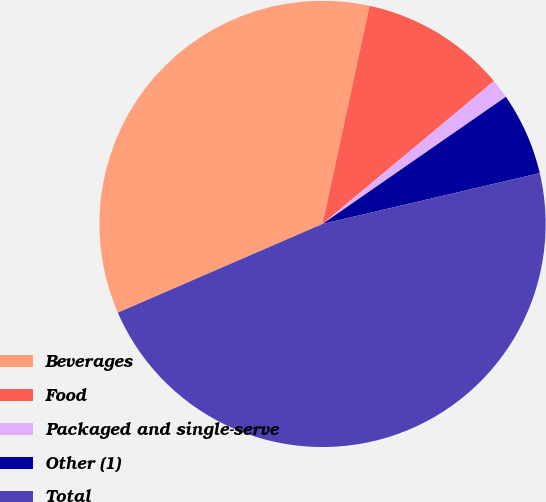Convert chart to OTSL. <chart><loc_0><loc_0><loc_500><loc_500><pie_chart><fcel>Beverages<fcel>Food<fcel>Packaged and single-serve<fcel>Other (1)<fcel>Total<nl><fcel>34.89%<fcel>10.56%<fcel>1.41%<fcel>5.99%<fcel>47.15%<nl></chart> 